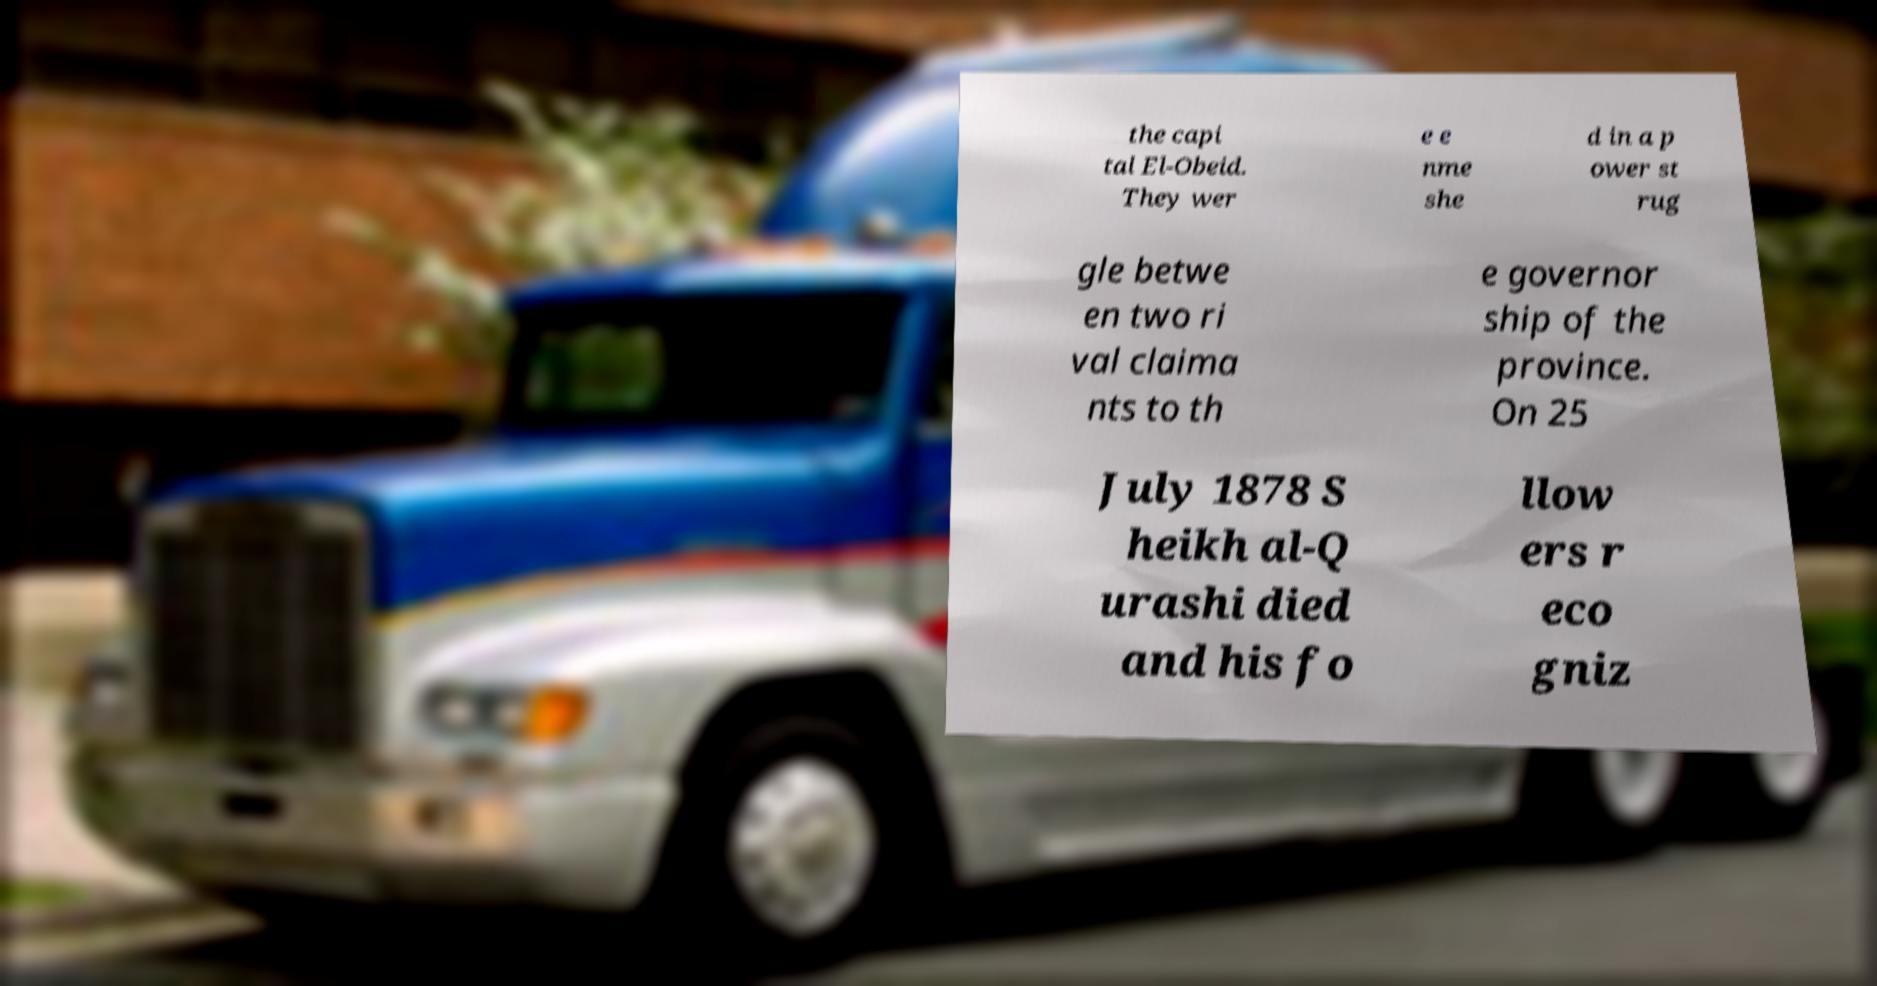Can you read and provide the text displayed in the image?This photo seems to have some interesting text. Can you extract and type it out for me? the capi tal El-Obeid. They wer e e nme she d in a p ower st rug gle betwe en two ri val claima nts to th e governor ship of the province. On 25 July 1878 S heikh al-Q urashi died and his fo llow ers r eco gniz 